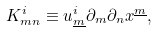Convert formula to latex. <formula><loc_0><loc_0><loc_500><loc_500>K ^ { i } _ { m n } \equiv u ^ { i } _ { \underline { m } } \partial _ { m } \partial _ { n } x ^ { \underline { m } } ,</formula> 